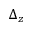<formula> <loc_0><loc_0><loc_500><loc_500>\Delta _ { z }</formula> 